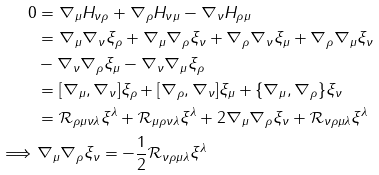Convert formula to latex. <formula><loc_0><loc_0><loc_500><loc_500>0 & = \nabla _ { \mu } H _ { \nu \rho } + \nabla _ { \rho } H _ { \nu \mu } - \nabla _ { \nu } H _ { \rho \mu } \\ & = \nabla _ { \mu } \nabla _ { \nu } \xi _ { \rho } + \nabla _ { \mu } \nabla _ { \rho } \xi _ { \nu } + \nabla _ { \rho } \nabla _ { \nu } \xi _ { \mu } + \nabla _ { \rho } \nabla _ { \mu } \xi _ { \nu } \\ & - \nabla _ { \nu } \nabla _ { \rho } \xi _ { \mu } - \nabla _ { \nu } \nabla _ { \mu } \xi _ { \rho } \\ & = [ \nabla _ { \mu } , \nabla _ { \nu } ] \xi _ { \rho } + [ \nabla _ { \rho } , \nabla _ { \nu } ] \xi _ { \mu } + \{ \nabla _ { \mu } , \nabla _ { \rho } \} \xi _ { \nu } \\ & = \mathcal { R } _ { \rho \mu \nu \lambda } \xi ^ { \lambda } + \mathcal { R } _ { \mu \rho \nu \lambda } \xi ^ { \lambda } + 2 \nabla _ { \mu } \nabla _ { \rho } \xi _ { \nu } + \mathcal { R } _ { \nu \rho \mu \lambda } \xi ^ { \lambda } \\ \implies & \nabla _ { \mu } \nabla _ { \rho } \xi _ { \nu } = - \frac { 1 } { 2 } \mathcal { R } _ { \nu \rho \mu \lambda } \xi ^ { \lambda }</formula> 